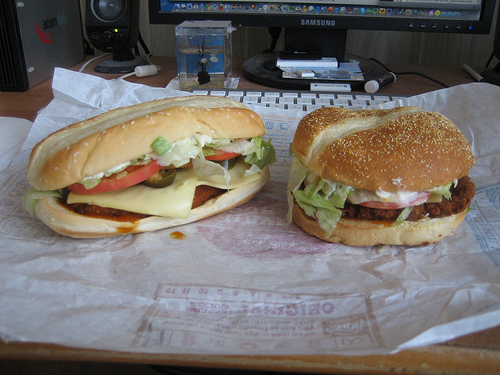What's the most eye-catching aspect of this meal setup? The lettuce and tomato between the unwrapped buns catch the eye with their fresh, vibrant colors. It's almost as if they're inviting you to take a bite. Describe the contrast between the two hamburgers in the image. One hamburger features a seeded bun with a classic shape, looking more traditional and rustic. The other is longer, with a more modern and glossy bun, hinting at different styles or perhaps varieties of sandwiches. Imagine a scenario where these hamburgers are a part of a gourmet meal. Write a detailed description of the scene. In a beautifully lit, rustic kitchen, a gourmet meal is being prepared. The air is filled with the aroma of freshly baked bread and sizzling patties. On the wooden counter, two distinct sandwiches stand majestically—a plump, seeded hamburger and a sleek, modern sub. Freshly grated provolone cheese peeks invitingly from under the warm buns, topped with crispy lettuce and juicy tomato slices. A side of golden, crispy fries complements the meal, placed in a rustic picnic-style basket lined with gingham cloth. The table is elegantly set with vintage plates and cutlery, with a bottle of homemade lemonade adding a refreshing touch to the ensemble. The entire setting whispers a casual yet sophisticated vibe, making it a perfect antidote to a hectic day. If these hamburgers could talk, what story would they tell about their creation and journey to the table? The hamburgers would probably share a tale of a passionate chef who meticulously chose the freshest ingredients from the local market. They'd tell a story of being lovingly crafted—each slice of tomato, each leaf of lettuce, chosen with care. They'd recount the moment they sizzled on the grill, the aroma tantalizing the senses. Finally, they'd describe how they were carefully assembled, each layer a testament to culinary art, before making their grand entrance onto the table, where they awaited the chance to surprise and delight diners. 